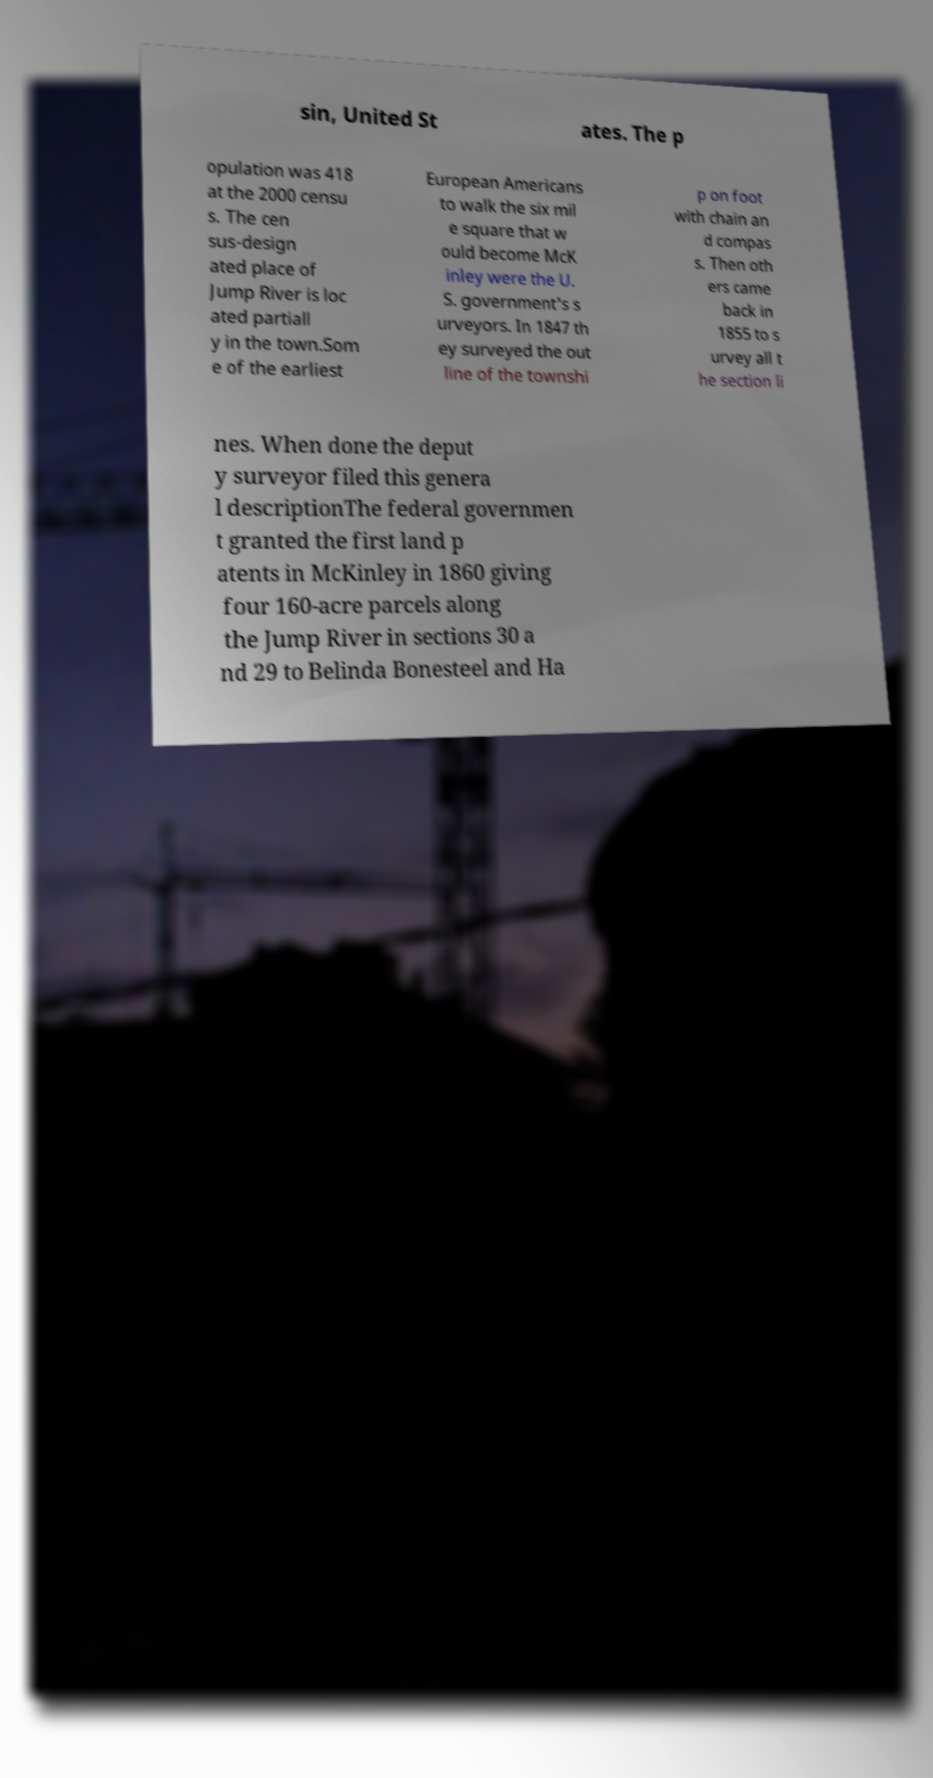Could you extract and type out the text from this image? sin, United St ates. The p opulation was 418 at the 2000 censu s. The cen sus-design ated place of Jump River is loc ated partiall y in the town.Som e of the earliest European Americans to walk the six mil e square that w ould become McK inley were the U. S. government's s urveyors. In 1847 th ey surveyed the out line of the townshi p on foot with chain an d compas s. Then oth ers came back in 1855 to s urvey all t he section li nes. When done the deput y surveyor filed this genera l descriptionThe federal governmen t granted the first land p atents in McKinley in 1860 giving four 160-acre parcels along the Jump River in sections 30 a nd 29 to Belinda Bonesteel and Ha 